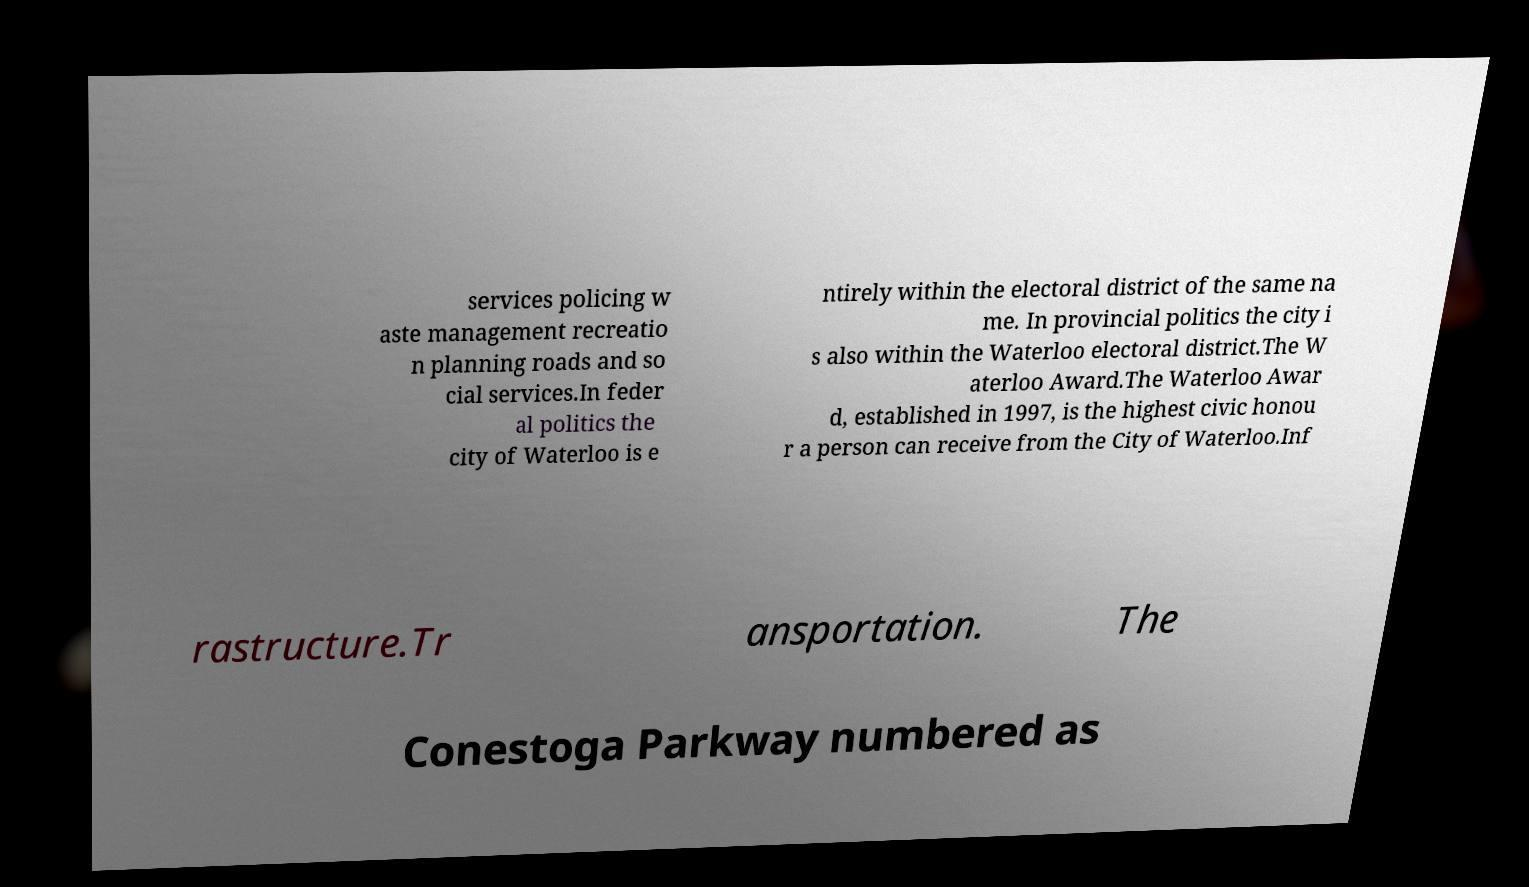For documentation purposes, I need the text within this image transcribed. Could you provide that? services policing w aste management recreatio n planning roads and so cial services.In feder al politics the city of Waterloo is e ntirely within the electoral district of the same na me. In provincial politics the city i s also within the Waterloo electoral district.The W aterloo Award.The Waterloo Awar d, established in 1997, is the highest civic honou r a person can receive from the City of Waterloo.Inf rastructure.Tr ansportation. The Conestoga Parkway numbered as 